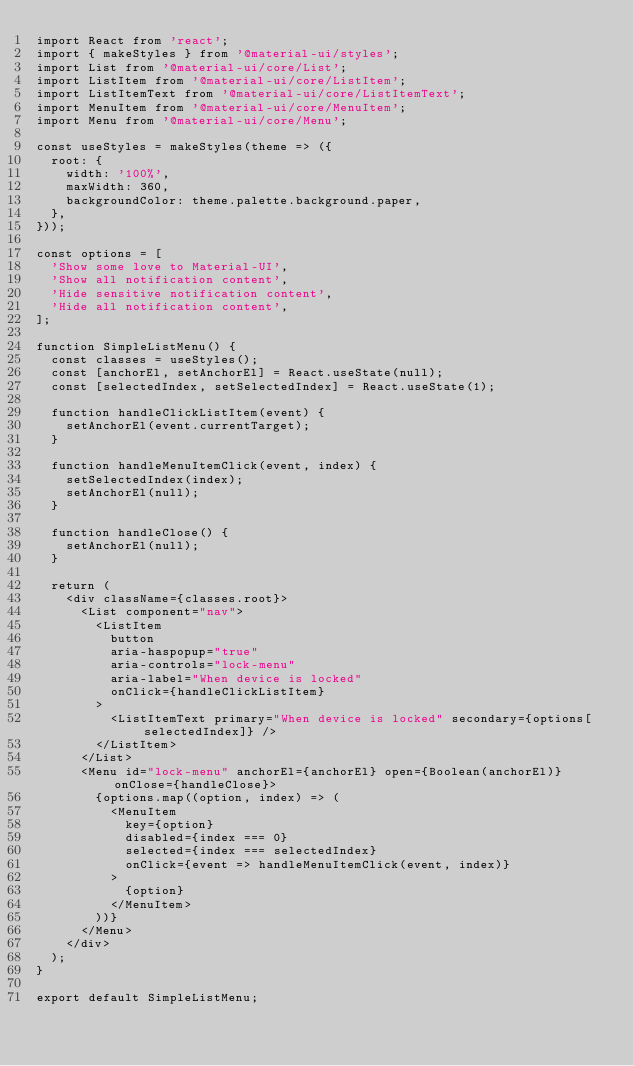<code> <loc_0><loc_0><loc_500><loc_500><_JavaScript_>import React from 'react';
import { makeStyles } from '@material-ui/styles';
import List from '@material-ui/core/List';
import ListItem from '@material-ui/core/ListItem';
import ListItemText from '@material-ui/core/ListItemText';
import MenuItem from '@material-ui/core/MenuItem';
import Menu from '@material-ui/core/Menu';

const useStyles = makeStyles(theme => ({
  root: {
    width: '100%',
    maxWidth: 360,
    backgroundColor: theme.palette.background.paper,
  },
}));

const options = [
  'Show some love to Material-UI',
  'Show all notification content',
  'Hide sensitive notification content',
  'Hide all notification content',
];

function SimpleListMenu() {
  const classes = useStyles();
  const [anchorEl, setAnchorEl] = React.useState(null);
  const [selectedIndex, setSelectedIndex] = React.useState(1);

  function handleClickListItem(event) {
    setAnchorEl(event.currentTarget);
  }

  function handleMenuItemClick(event, index) {
    setSelectedIndex(index);
    setAnchorEl(null);
  }

  function handleClose() {
    setAnchorEl(null);
  }

  return (
    <div className={classes.root}>
      <List component="nav">
        <ListItem
          button
          aria-haspopup="true"
          aria-controls="lock-menu"
          aria-label="When device is locked"
          onClick={handleClickListItem}
        >
          <ListItemText primary="When device is locked" secondary={options[selectedIndex]} />
        </ListItem>
      </List>
      <Menu id="lock-menu" anchorEl={anchorEl} open={Boolean(anchorEl)} onClose={handleClose}>
        {options.map((option, index) => (
          <MenuItem
            key={option}
            disabled={index === 0}
            selected={index === selectedIndex}
            onClick={event => handleMenuItemClick(event, index)}
          >
            {option}
          </MenuItem>
        ))}
      </Menu>
    </div>
  );
}

export default SimpleListMenu;
</code> 